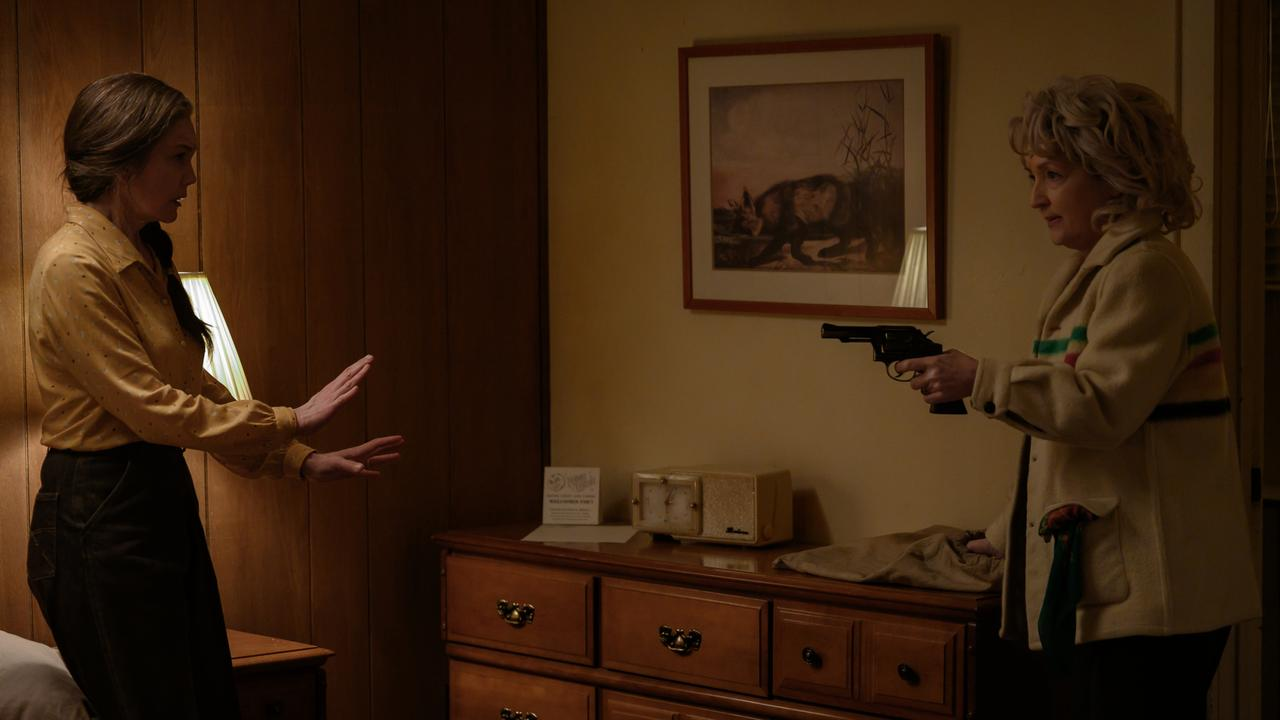How might this scene be different if it occurred in an outdoor setting? If this confrontation occurred in an outdoor setting, the dynamic and elements would shift significantly. Imagine the sharegpt4v/same intense standoff in a secluded forest clearing at dusk. The natural surroundings would add an eerie silence, broken only by the sounds of nature, heightening the suspense. The dimming light would cast long shadows, creating a foreboding atmosphere.

The woman in the yellow blouse might be backed against an imposing tree, with leaves rustling in the wind behind her. The woman with the gun could be standing on uneven ground, her stance slightly precarious, adding a layer of unpredictability to the scene. Instead of wooden paneling, the dense foliage and towering trees would enclose them, mirroring the isolation and confinement of the original indoor setting while adding a raw, primal edge to the tension. Given the outdoor setting, explore the possible symbolism of the forest in this confrontation. In the outdoor setting, the forest could symbolize multiple thematic elements relevant to the confrontation. The dense trees and tangled underbrush could represent the complexity of the characters' relationship and the tangled web of secrets that led them to this moment. The forest's isolation mirrors their emotional isolation, each woman trapped in her narrative and truth.

The twilight setting could symbolize the fading light of their trust and the encroaching darkness of their conflict. Nature, in its untamed state, often reflects the raw, unfiltered emotions of the characters, with the forest becoming a silent witness to their primal struggle. The presence of natural obstacles, like fallen branches or hidden roots, might also symbolize the unexpected challenges and hidden truths they must navigate to reach a resolution. 